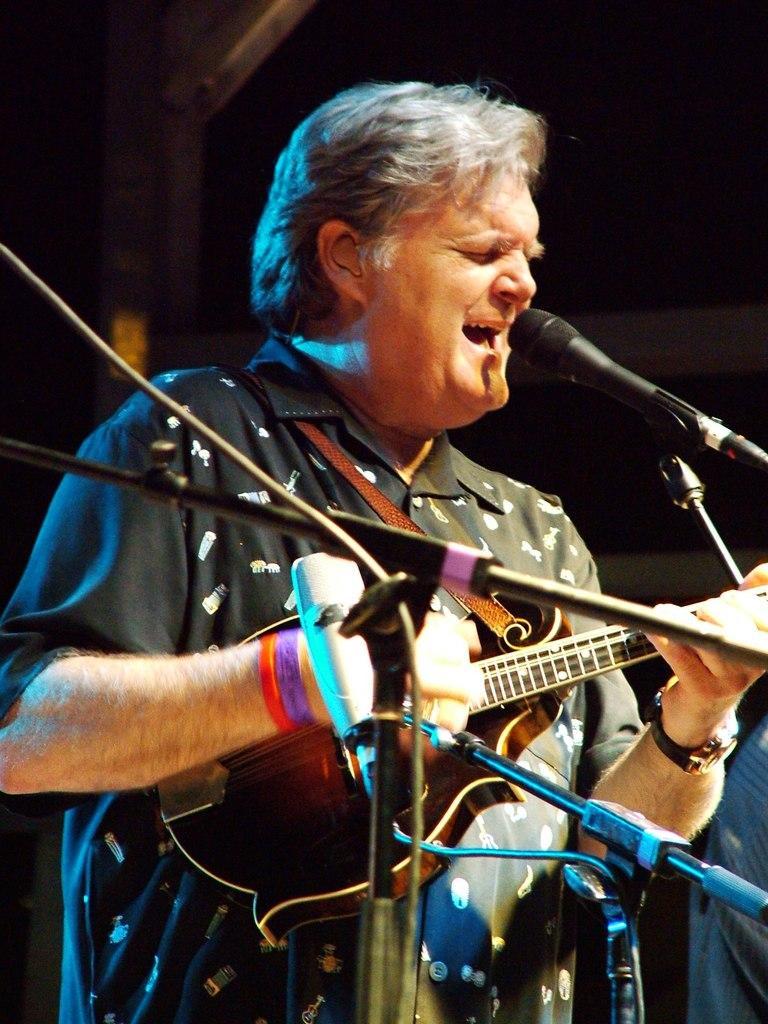How would you summarize this image in a sentence or two? In this picture, we see the man in the black shirt is standing and he is holding a guitar in his hand. In front of him, we see the microphones. He is playing the guitar and he is singing the song on the microphone. In the background, we see the wooden poles. In the background, it is black in color. 